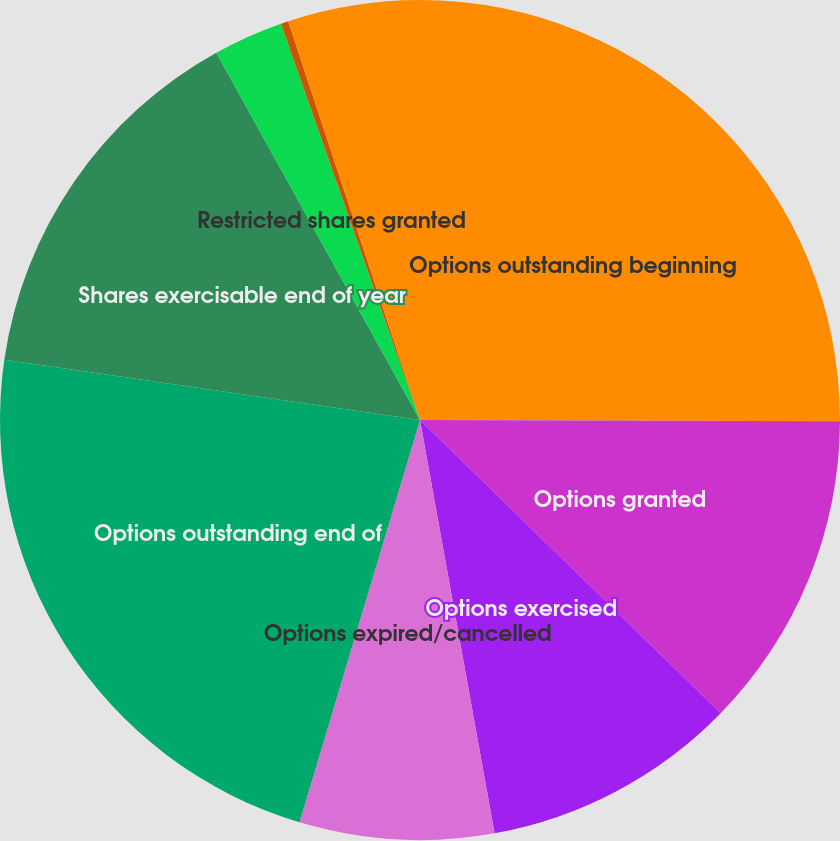Convert chart. <chart><loc_0><loc_0><loc_500><loc_500><pie_chart><fcel>Options outstanding beginning<fcel>Options granted<fcel>Options exercised<fcel>Options expired/cancelled<fcel>Options outstanding end of<fcel>Shares exercisable end of year<fcel>Restricted shares granted<fcel>Restricted shares vested<fcel>Restricted shares outstanding<nl><fcel>25.05%<fcel>12.25%<fcel>9.86%<fcel>7.47%<fcel>22.66%<fcel>14.65%<fcel>2.69%<fcel>0.29%<fcel>5.08%<nl></chart> 